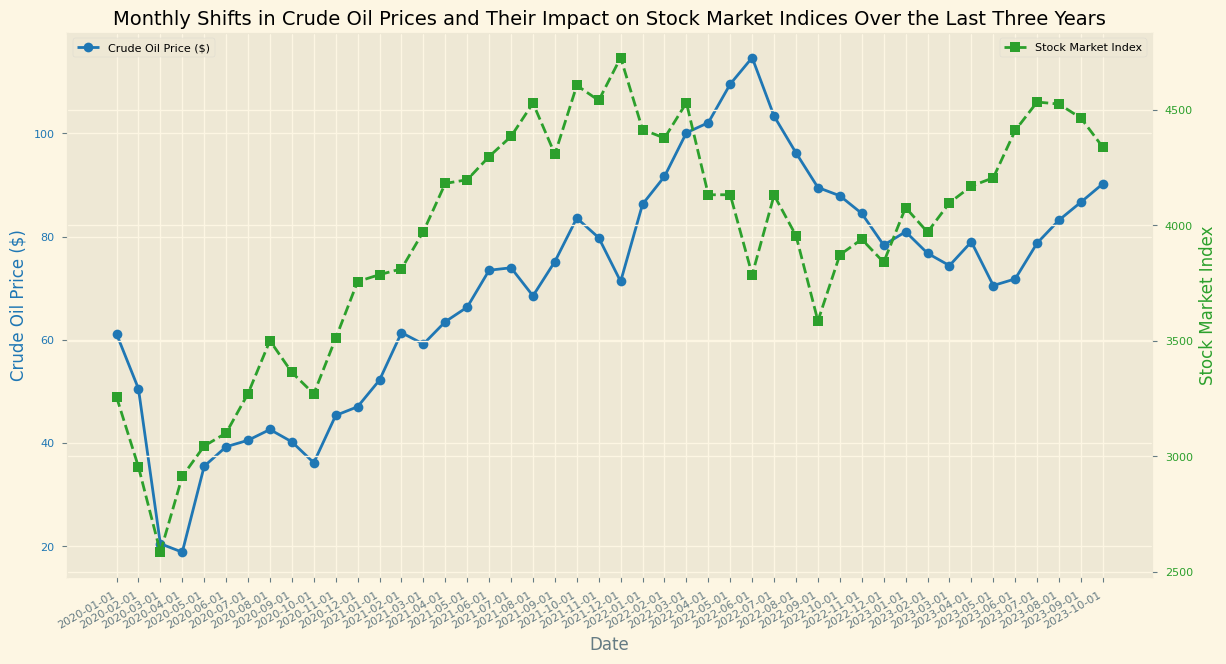How did crude oil prices trend from January 2020 to October 2023? To determine the trend, observe the blue line representing crude oil prices over the time period. Note any patterns or significant changes. The prices dropped sharply around March 2020, then gradually increased until mid-2022, fluctuated thereafter, and slightly decreased towards October 2023.
Answer: Upward with fluctuations During which period did crude oil prices see their sharpest decline, and what was the effect on the stock market index? Identify the steepest downward slope in the blue line. This occurs around February to April 2020. Check how it aligns with the green line representing stock market indices. The stock market index also fell significantly during this period.
Answer: February to April 2020, sharp decline What was the highest crude oil price recorded in the last three years, and which month did it occur? Look for the peak point on the blue line. The highest price is around $114.67, which occurred in June 2022.
Answer: June 2022, $114.67 Compare the stock market index in January 2021 and January 2023. Which month showed a higher index value? Locate January 2021 and January 2023 on the x-axis and compare the heights of the green line at these points. The index is higher in January 2023.
Answer: January 2023 What was the relationship between crude oil prices and the stock market index between April 2020 and December 2020? Examine the blue and green lines between these months. Crude oil prices increased from $18.84 to $47.02, and the stock market index rose from 2912.43 to 3756.07, suggesting a positive correlation.
Answer: Positive correlation Which month experienced the lowest stock market index value? Find the lowest point on the green line and identify the corresponding date. This occurred in March 2020.
Answer: March 2020 How did the stock market index change from October 2022 to October 2023? Note the value of the green line at these two points and compare. The index decreased from 3871.98 to 4337.55, indicating an increase.
Answer: Increased Calculate the difference between the crude oil prices in August 2021 and August 2023. Identify the crude oil prices in August 2021 ($68.50) and August 2023 ($83.19), then subtract the former from the latter. $83.19 - $68.50 = $14.69.
Answer: $14.69 What visual pattern can be observed when crude oil prices fluctuate between $40 and $50? Observe the blue line in this price range and note how frequently these fluctuations occur. This generally corresponds to periods of slight increase or decrease in the stock market index.
Answer: Fluctuations are periods of slight market movements Did the stock market index reach a peak before or after June 2022? Identify June 2022 on the green line and check values before and after. The peak occurred after June 2022.
Answer: After June 2022 